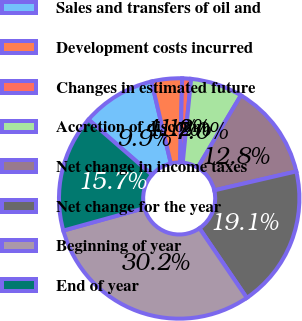Convert chart. <chart><loc_0><loc_0><loc_500><loc_500><pie_chart><fcel>Sales and transfers of oil and<fcel>Development costs incurred<fcel>Changes in estimated future<fcel>Accretion of discount<fcel>Net change in income taxes<fcel>Net change for the year<fcel>Beginning of year<fcel>End of year<nl><fcel>9.9%<fcel>4.1%<fcel>1.19%<fcel>7.0%<fcel>12.8%<fcel>19.11%<fcel>30.21%<fcel>15.7%<nl></chart> 